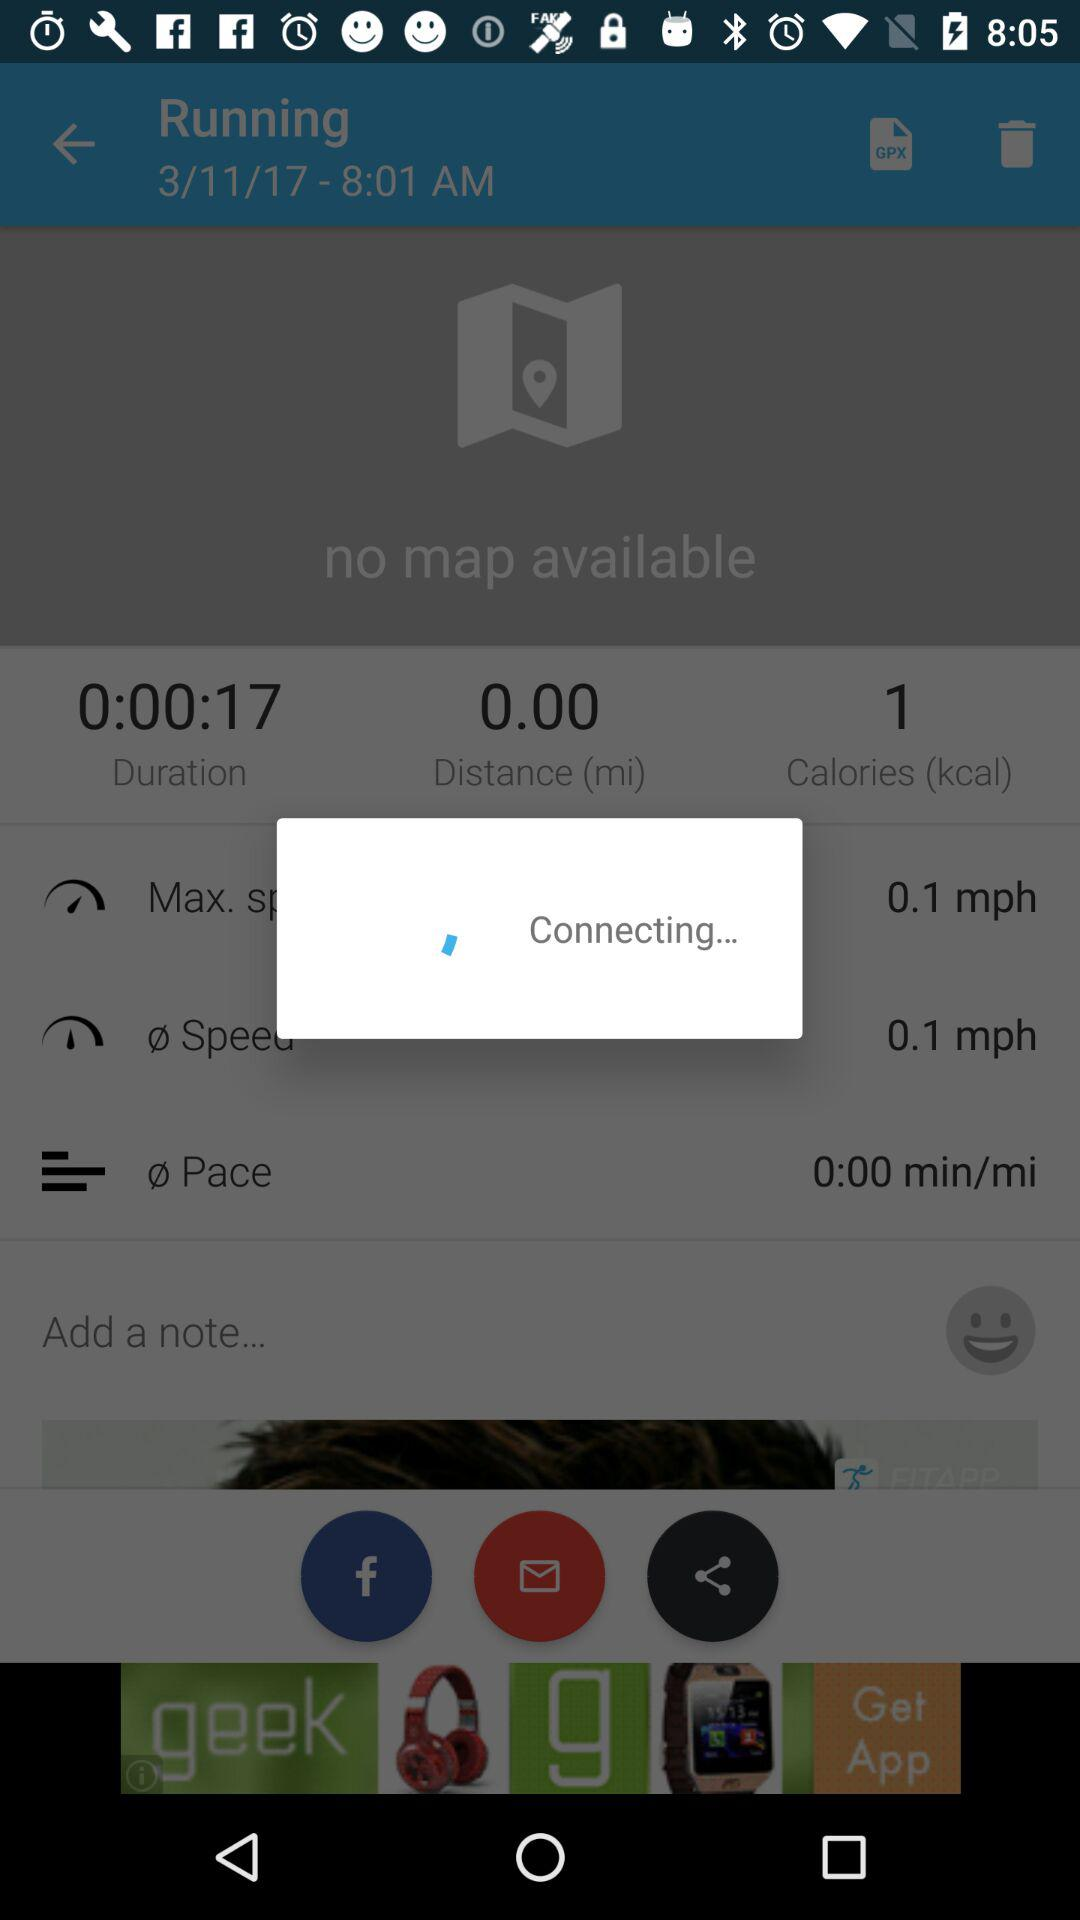How long has the user been running for?
Answer the question using a single word or phrase. 0:00:00 